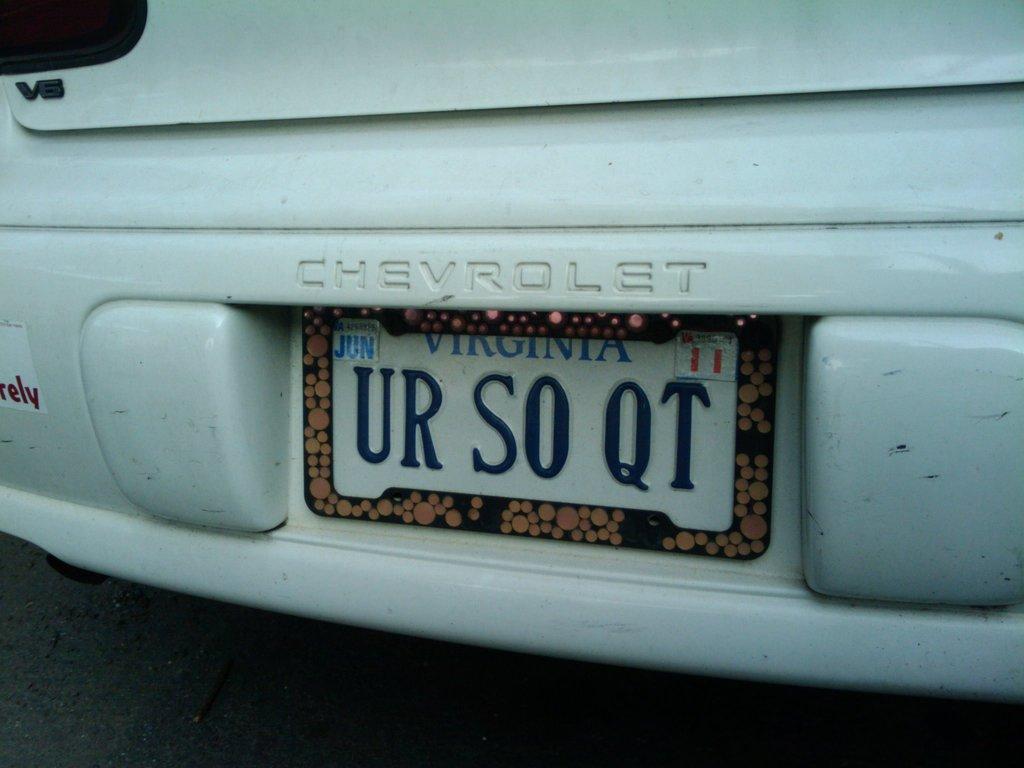Which state is this car from?
Offer a terse response. Virginia. 